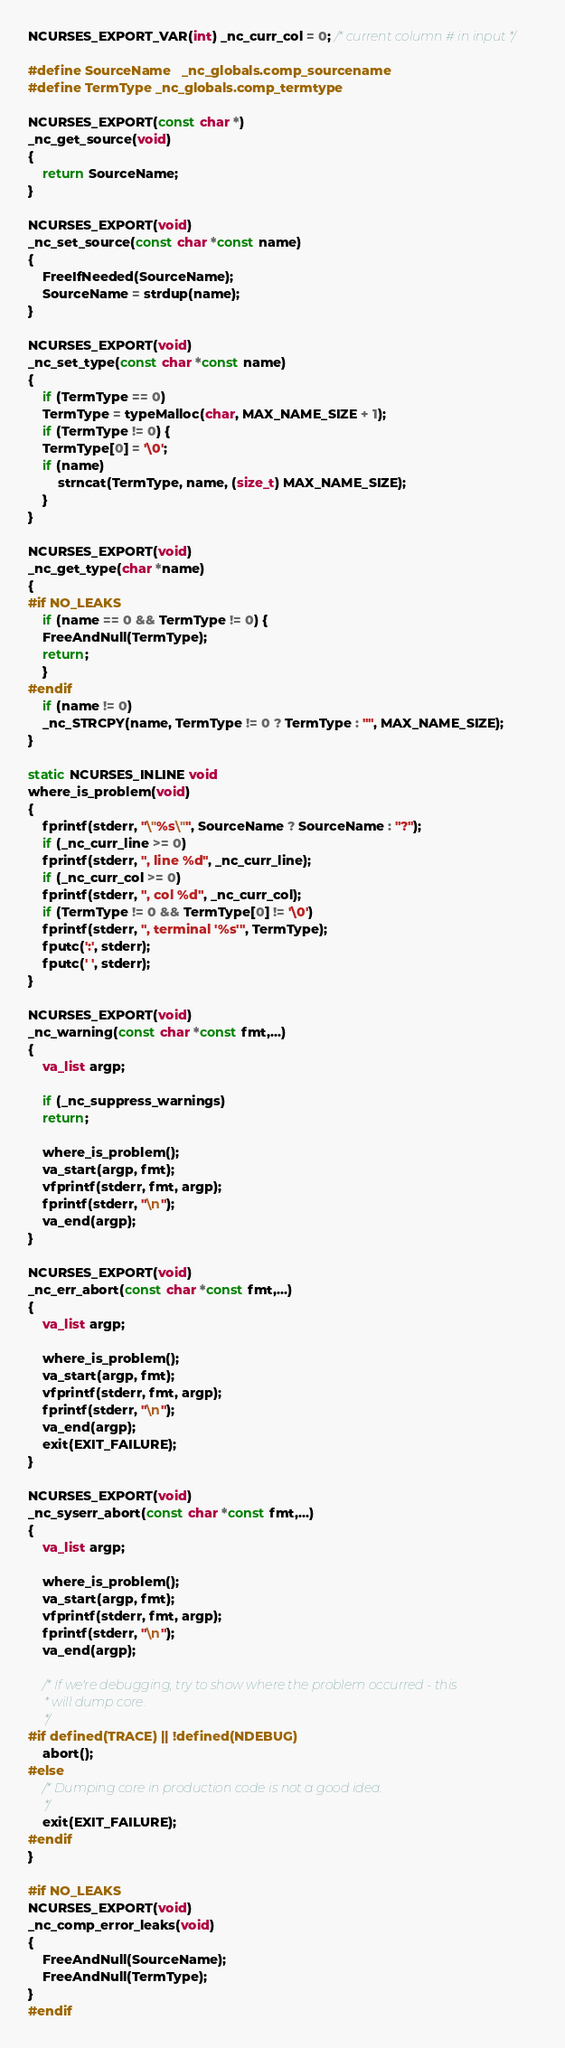<code> <loc_0><loc_0><loc_500><loc_500><_C_>NCURSES_EXPORT_VAR(int) _nc_curr_col = 0; /* current column # in input */

#define SourceName	_nc_globals.comp_sourcename
#define TermType	_nc_globals.comp_termtype

NCURSES_EXPORT(const char *)
_nc_get_source(void)
{
    return SourceName;
}

NCURSES_EXPORT(void)
_nc_set_source(const char *const name)
{
    FreeIfNeeded(SourceName);
    SourceName = strdup(name);
}

NCURSES_EXPORT(void)
_nc_set_type(const char *const name)
{
    if (TermType == 0)
	TermType = typeMalloc(char, MAX_NAME_SIZE + 1);
    if (TermType != 0) {
	TermType[0] = '\0';
	if (name)
	    strncat(TermType, name, (size_t) MAX_NAME_SIZE);
    }
}

NCURSES_EXPORT(void)
_nc_get_type(char *name)
{
#if NO_LEAKS
    if (name == 0 && TermType != 0) {
	FreeAndNull(TermType);
	return;
    }
#endif
    if (name != 0)
	_nc_STRCPY(name, TermType != 0 ? TermType : "", MAX_NAME_SIZE);
}

static NCURSES_INLINE void
where_is_problem(void)
{
    fprintf(stderr, "\"%s\"", SourceName ? SourceName : "?");
    if (_nc_curr_line >= 0)
	fprintf(stderr, ", line %d", _nc_curr_line);
    if (_nc_curr_col >= 0)
	fprintf(stderr, ", col %d", _nc_curr_col);
    if (TermType != 0 && TermType[0] != '\0')
	fprintf(stderr, ", terminal '%s'", TermType);
    fputc(':', stderr);
    fputc(' ', stderr);
}

NCURSES_EXPORT(void)
_nc_warning(const char *const fmt,...)
{
    va_list argp;

    if (_nc_suppress_warnings)
	return;

    where_is_problem();
    va_start(argp, fmt);
    vfprintf(stderr, fmt, argp);
    fprintf(stderr, "\n");
    va_end(argp);
}

NCURSES_EXPORT(void)
_nc_err_abort(const char *const fmt,...)
{
    va_list argp;

    where_is_problem();
    va_start(argp, fmt);
    vfprintf(stderr, fmt, argp);
    fprintf(stderr, "\n");
    va_end(argp);
    exit(EXIT_FAILURE);
}

NCURSES_EXPORT(void)
_nc_syserr_abort(const char *const fmt,...)
{
    va_list argp;

    where_is_problem();
    va_start(argp, fmt);
    vfprintf(stderr, fmt, argp);
    fprintf(stderr, "\n");
    va_end(argp);

    /* If we're debugging, try to show where the problem occurred - this
     * will dump core.
     */
#if defined(TRACE) || !defined(NDEBUG)
    abort();
#else
    /* Dumping core in production code is not a good idea.
     */
    exit(EXIT_FAILURE);
#endif
}

#if NO_LEAKS
NCURSES_EXPORT(void)
_nc_comp_error_leaks(void)
{
    FreeAndNull(SourceName);
    FreeAndNull(TermType);
}
#endif
</code> 